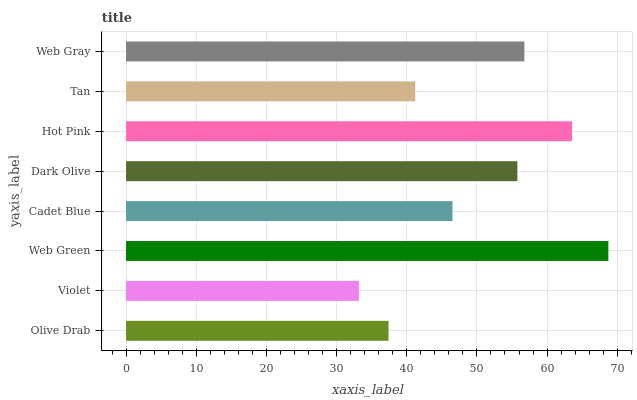Is Violet the minimum?
Answer yes or no. Yes. Is Web Green the maximum?
Answer yes or no. Yes. Is Web Green the minimum?
Answer yes or no. No. Is Violet the maximum?
Answer yes or no. No. Is Web Green greater than Violet?
Answer yes or no. Yes. Is Violet less than Web Green?
Answer yes or no. Yes. Is Violet greater than Web Green?
Answer yes or no. No. Is Web Green less than Violet?
Answer yes or no. No. Is Dark Olive the high median?
Answer yes or no. Yes. Is Cadet Blue the low median?
Answer yes or no. Yes. Is Violet the high median?
Answer yes or no. No. Is Tan the low median?
Answer yes or no. No. 